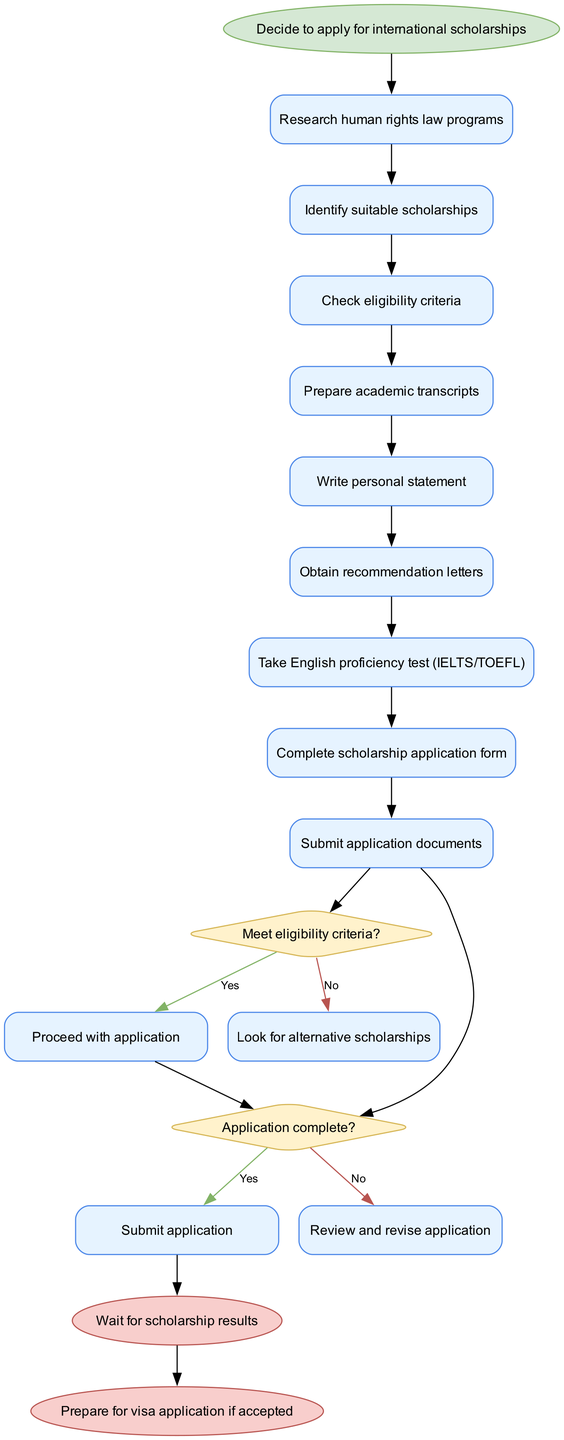What is the starting point of the scholarship application process? The diagram clearly indicates that the process begins with the decision to apply for international scholarships, which is highlighted as the first node.
Answer: Decide to apply for international scholarships How many activities are listed in the diagram? By counting each activity node presented in the diagram, we find a total of nine activities.
Answer: 9 What is the first activity in the diagram? The first activity node that follows the starting point is "Research human rights law programs," which is the initial task.
Answer: Research human rights law programs What happens if the eligibility criteria are not met? According to the decision node, if the eligibility criteria are not met, the next action is to "Look for alternative scholarships." This is specified as a corresponding flow from the decision node.
Answer: Look for alternative scholarships How many decision points are in the diagram? The diagram includes two decision points where the flow of the process can diverge based on certain conditions, each represented by a diamond-shaped node.
Answer: 2 What is the outcome if the scholarship application is complete? If the application is complete, the flow moves to the next step where the action is to "Submit application," as indicated by the connections from the decision node.
Answer: Submit application What should be done if the application is not complete? The diagram indicates that if the application is not complete, the next step is to "Review and revise application," clearly specifying what actions to take.
Answer: Review and revise application What is the final outcome of the scholarship application process? The diagram concludes with two possibilities, either to "Wait for scholarship results" or to "Prepare for visa application if accepted." This is specified at the endpoint nodes.
Answer: Wait for scholarship results or Prepare for visa application if accepted 